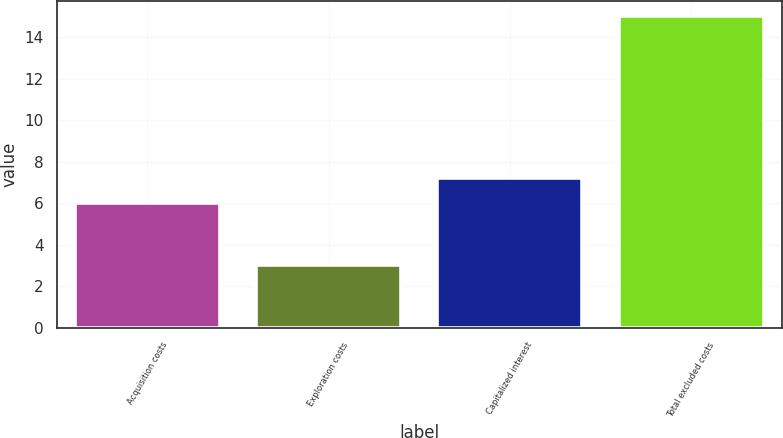<chart> <loc_0><loc_0><loc_500><loc_500><bar_chart><fcel>Acquisition costs<fcel>Exploration costs<fcel>Capitalized interest<fcel>Total excluded costs<nl><fcel>6<fcel>3<fcel>7.2<fcel>15<nl></chart> 